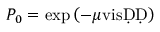Convert formula to latex. <formula><loc_0><loc_0><loc_500><loc_500>P _ { 0 } = \exp \left ( - \mu v i s \right )</formula> 